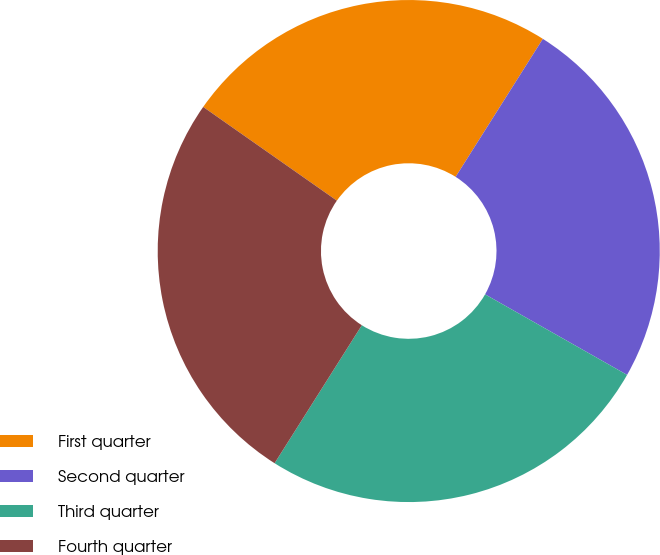Convert chart to OTSL. <chart><loc_0><loc_0><loc_500><loc_500><pie_chart><fcel>First quarter<fcel>Second quarter<fcel>Third quarter<fcel>Fourth quarter<nl><fcel>24.24%<fcel>24.24%<fcel>25.76%<fcel>25.76%<nl></chart> 